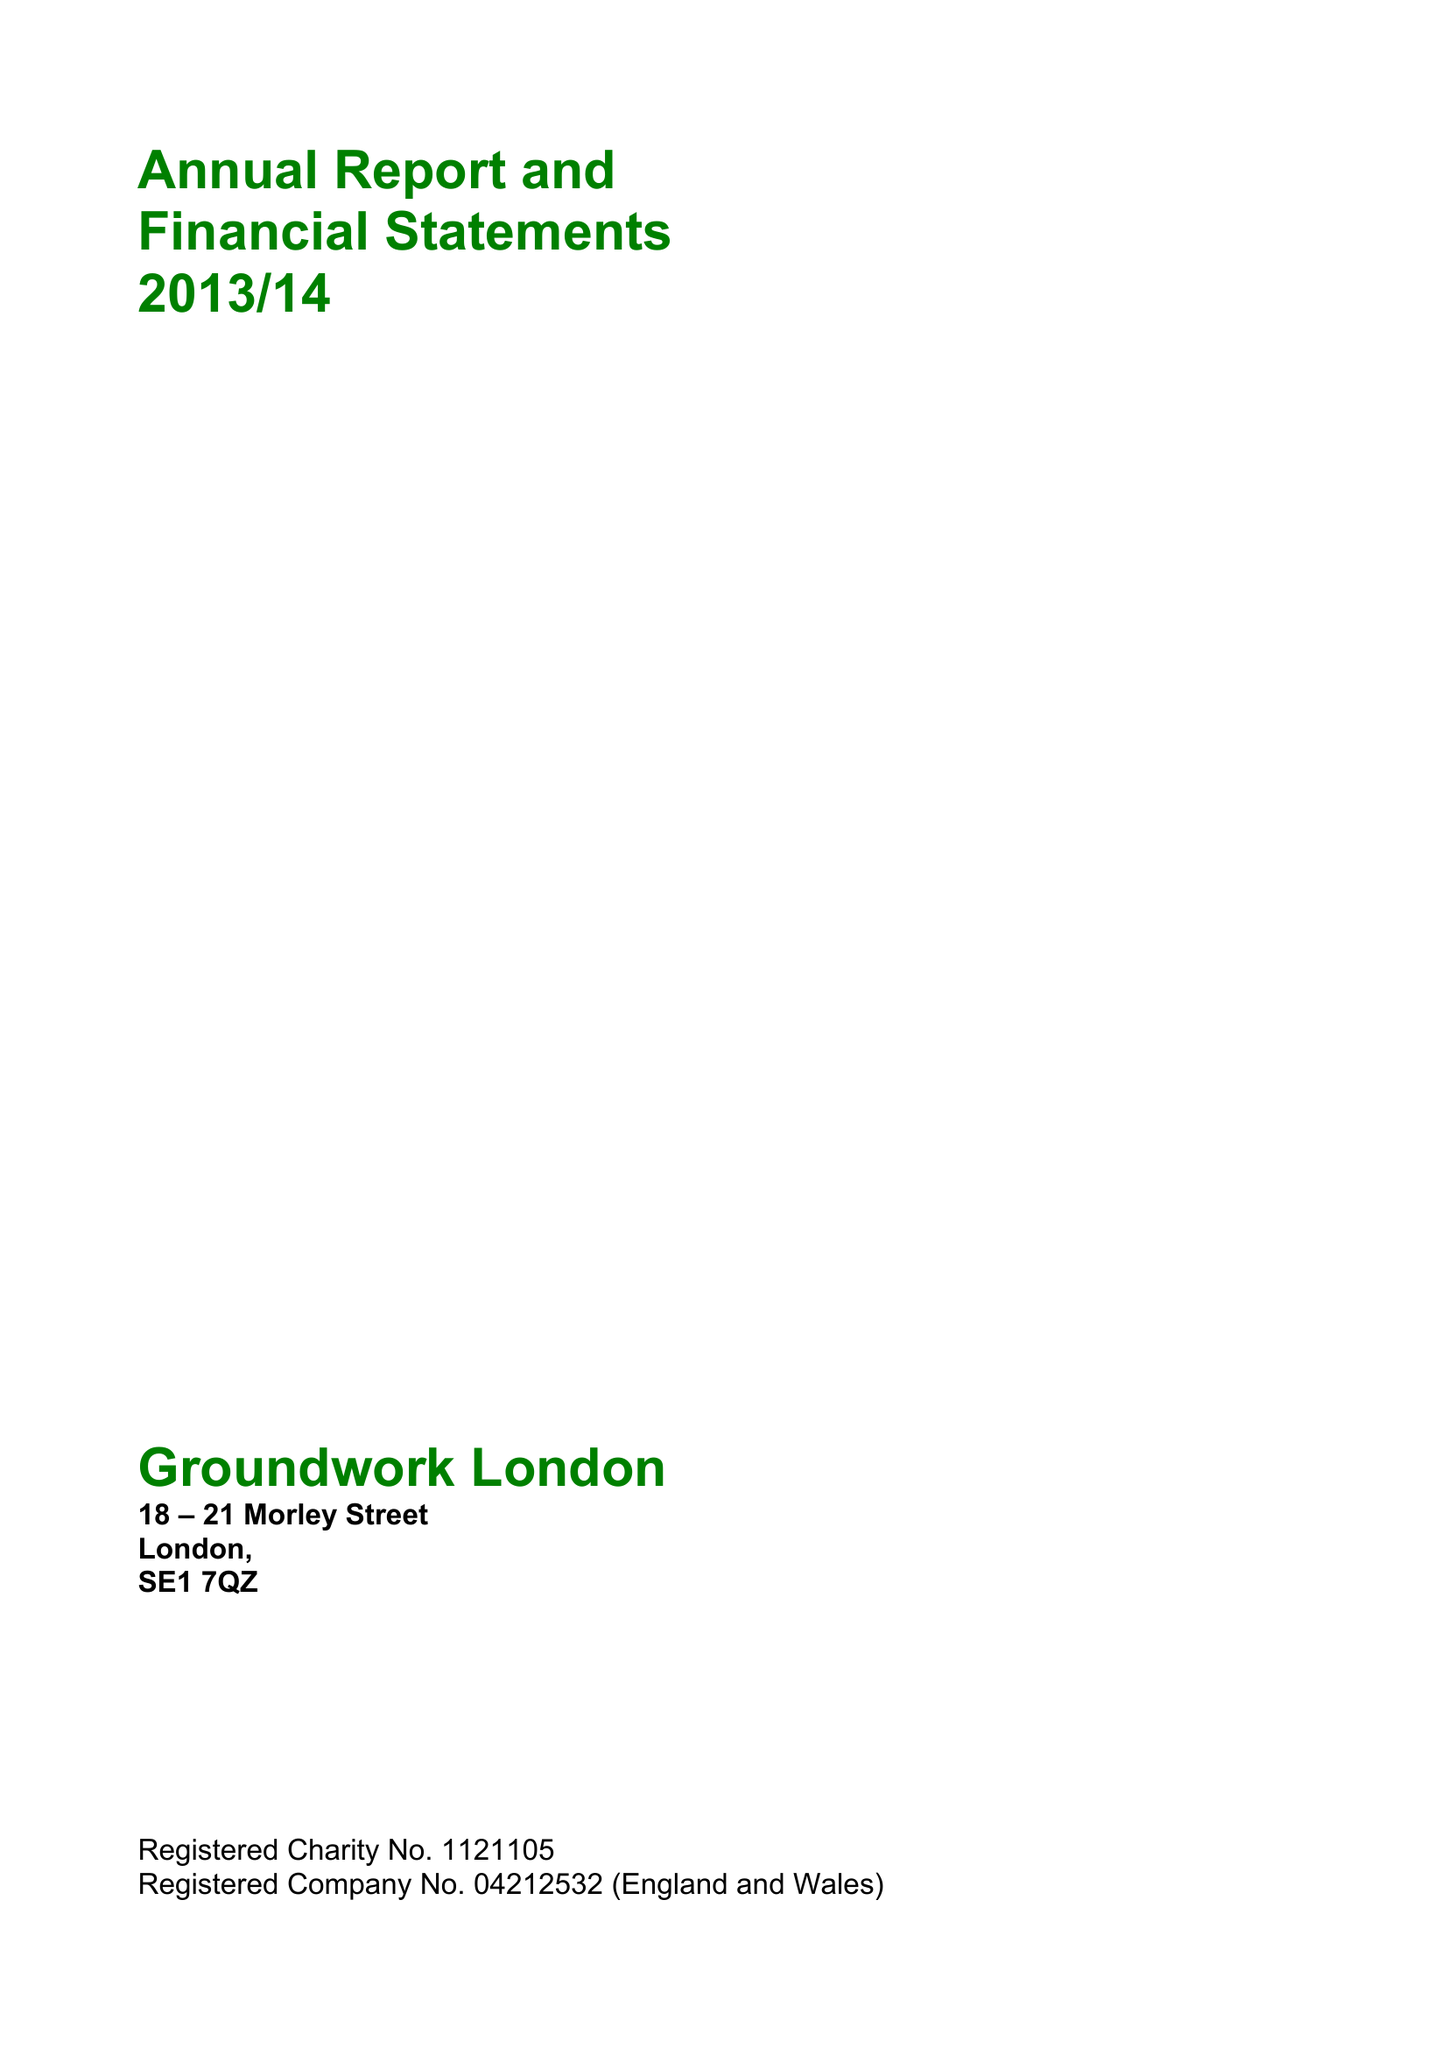What is the value for the charity_number?
Answer the question using a single word or phrase. 1121105 